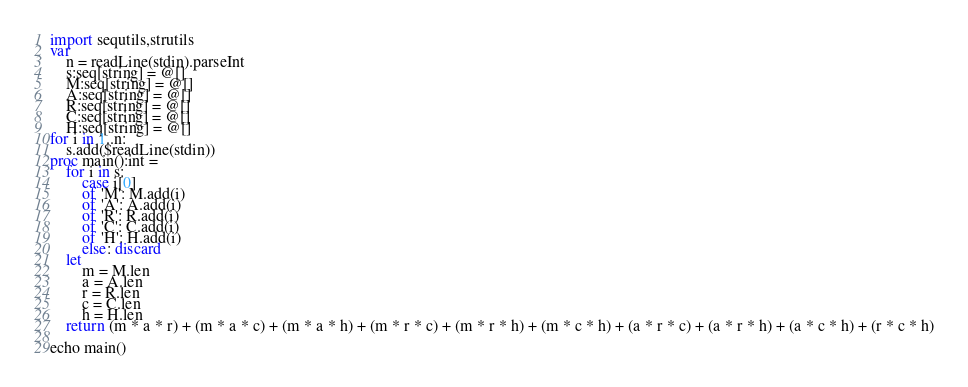Convert code to text. <code><loc_0><loc_0><loc_500><loc_500><_Nim_>import sequtils,strutils
var
    n = readLine(stdin).parseInt
    s:seq[string] = @[]
    M:seq[string] = @[]
    A:seq[string] = @[]
    R:seq[string] = @[]
    C:seq[string] = @[]
    H:seq[string] = @[]
for i in 1..n:
    s.add($readLine(stdin))
proc main():int =
    for i in s:
        case i[0]
        of 'M': M.add(i)
        of 'A': A.add(i)
        of 'R': R.add(i)
        of 'C': C.add(i)
        of 'H': H.add(i)
        else: discard
    let
        m = M.len
        a = A.len
        r = R.len
        c = C.len
        h = H.len
    return (m * a * r) + (m * a * c) + (m * a * h) + (m * r * c) + (m * r * h) + (m * c * h) + (a * r * c) + (a * r * h) + (a * c * h) + (r * c * h)

echo main()
</code> 